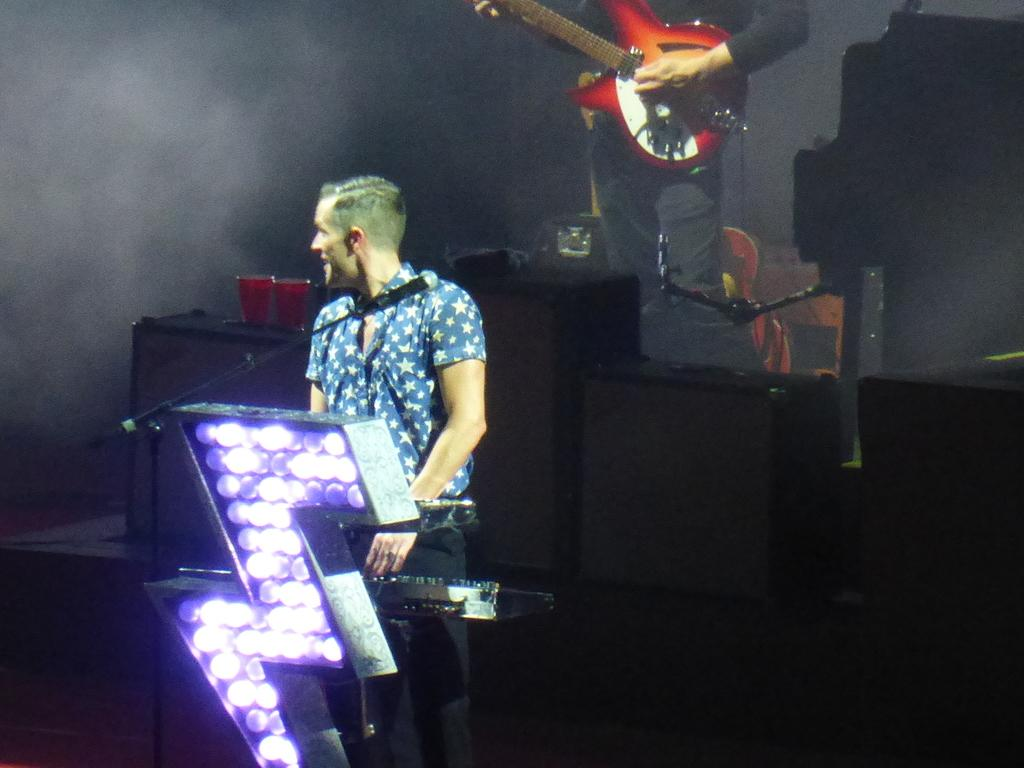What is the main subject of the image? The main subject of the image is a man standing in front of a Casio. Can you describe the man's surroundings? There is a person standing at the back of the man, and this person is holding a guitar. What brand of electronic device is the man using? The man has a Casio in front of him. How many icicles are hanging from the man's clothing in the image? There are no icicles present in the image. What type of pull-up bar is the man using in the image? The image does not show the man using a pull-up bar; he is standing in front of a Casio. 